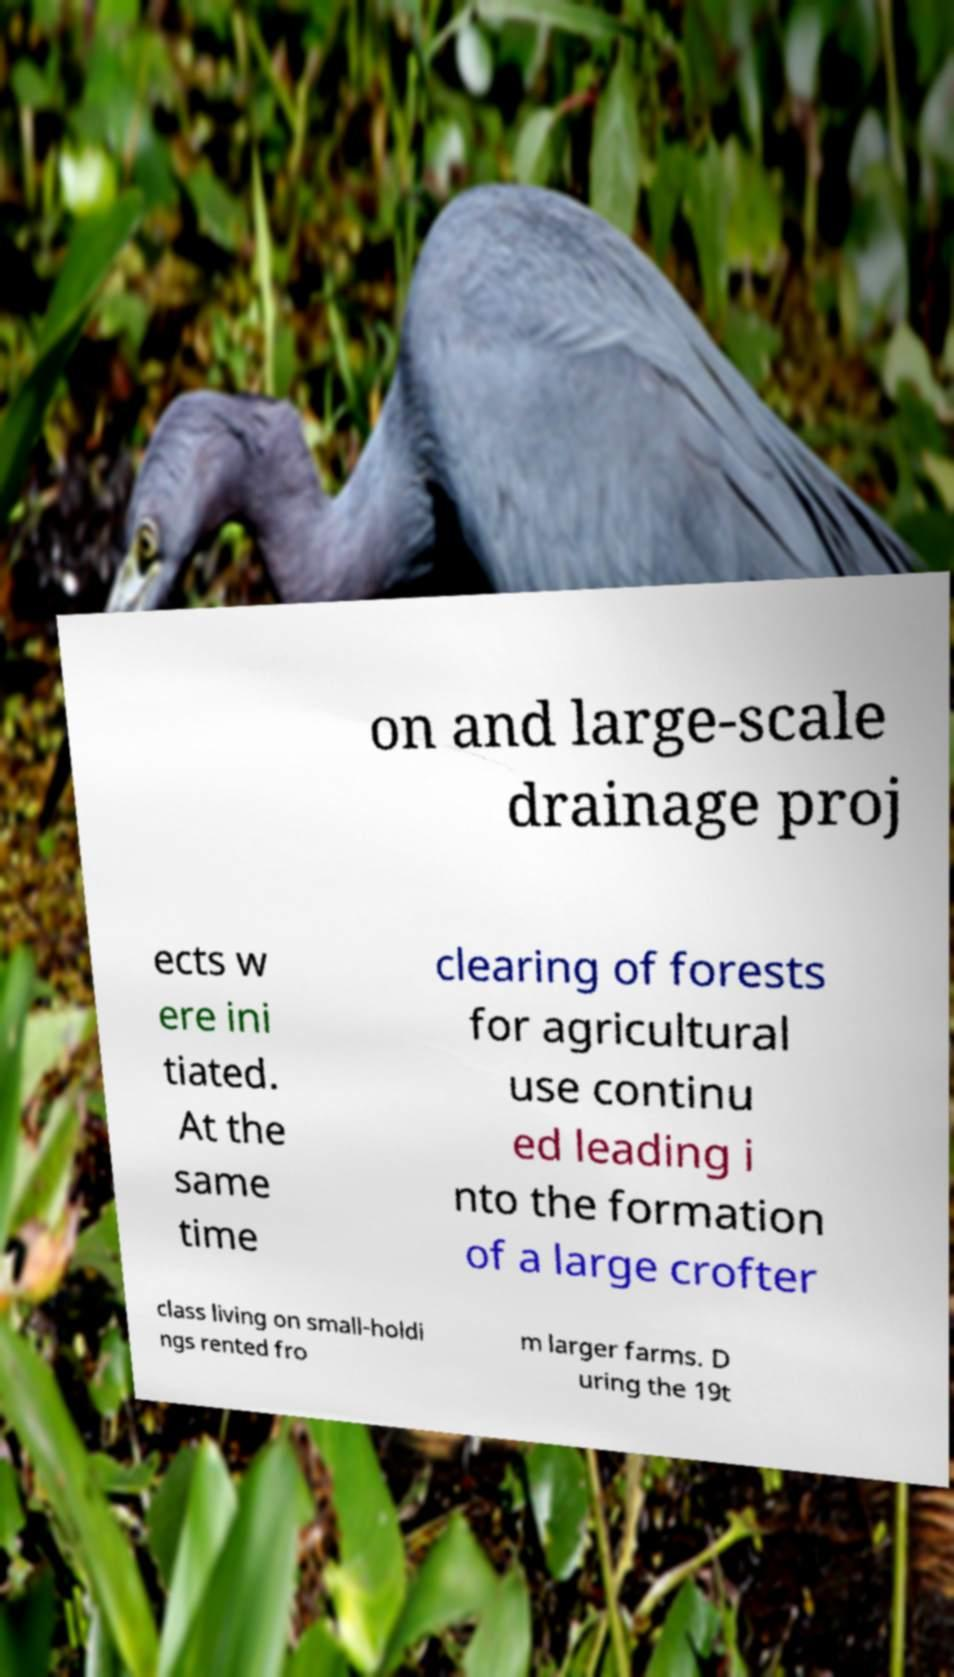What messages or text are displayed in this image? I need them in a readable, typed format. on and large-scale drainage proj ects w ere ini tiated. At the same time clearing of forests for agricultural use continu ed leading i nto the formation of a large crofter class living on small-holdi ngs rented fro m larger farms. D uring the 19t 